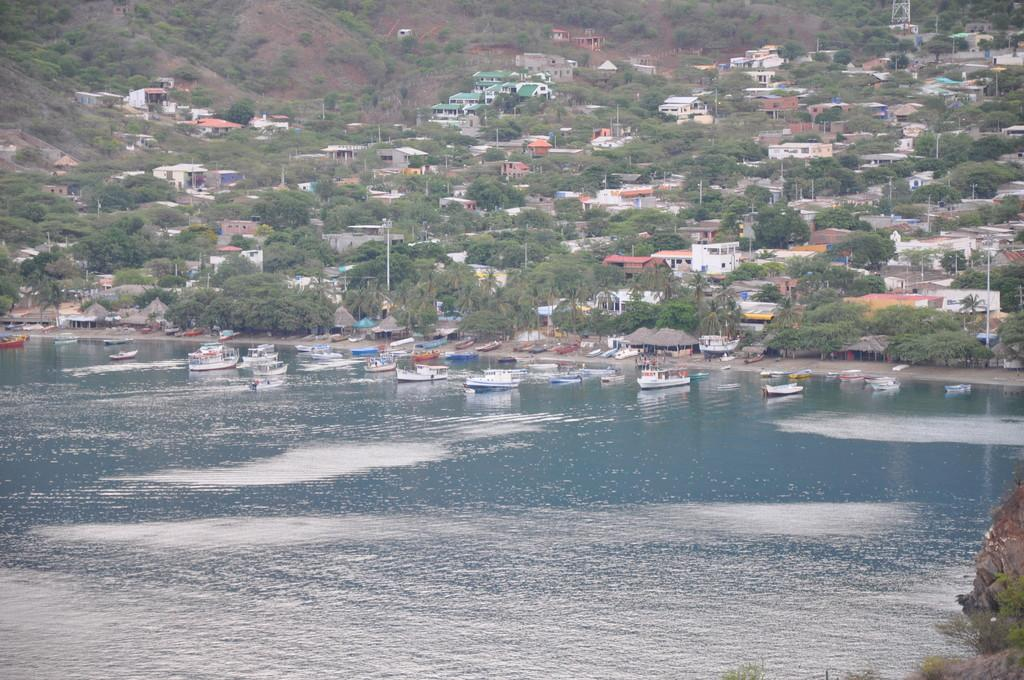What is on the water in the image? There are boats on the water in the image. What can be seen in the background of the image? There are trees and buildings in the background of the image. What is the color of the trees in the image? The trees are green in the image. What colors are present on the buildings in the background? The buildings have white, cream, and green colors. What else is visible in the image besides the boats, trees, and buildings? There are poles visible in the image. Can you tell me what type of camera the lawyer is using to take a picture of the attraction in the image? There is no lawyer, camera, or attraction present in the image. 